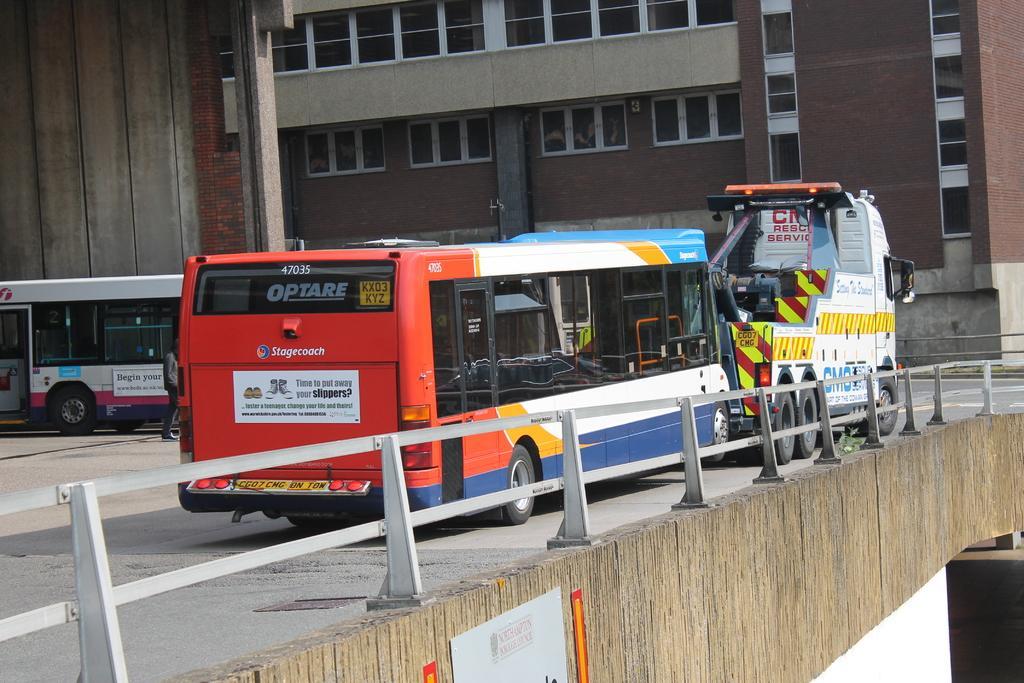Could you give a brief overview of what you see in this image? This image is taken outdoors. At the bottom of the image there is a bridge with a ring, a pillar and a board with a text on it. In the middle of the image a few vehicles are moving on the road. In the background there is a building with walls, windows and doors. 